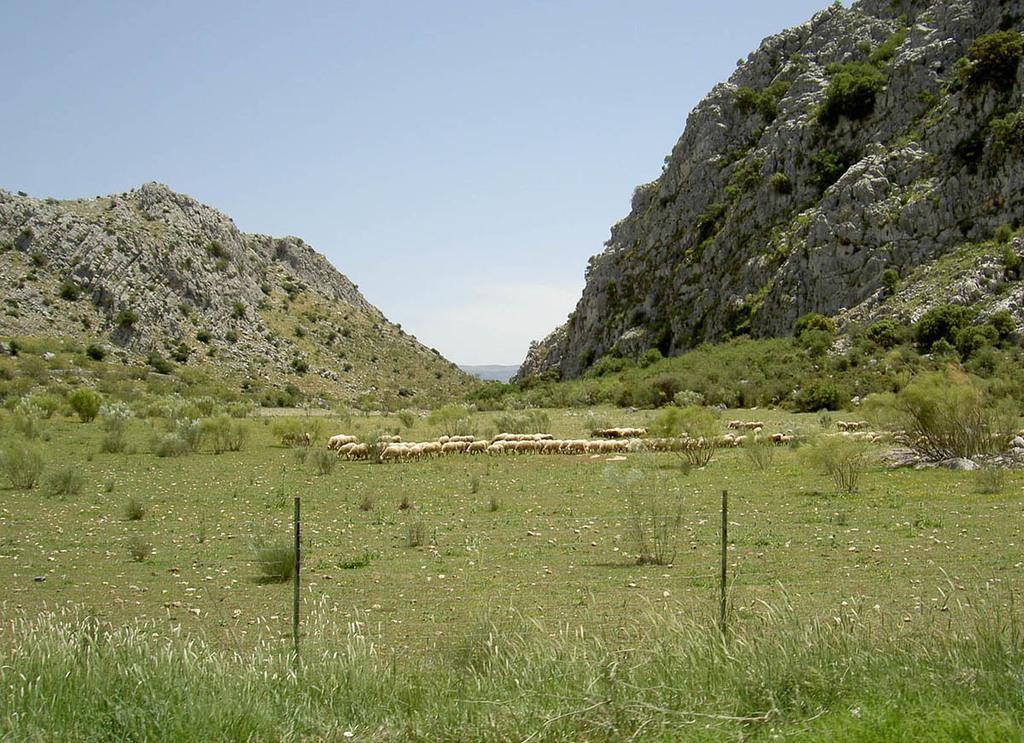Please provide a concise description of this image. In the center of the image there are sheeps. There is grass. In the background of the image there are mountains. There is sky. 